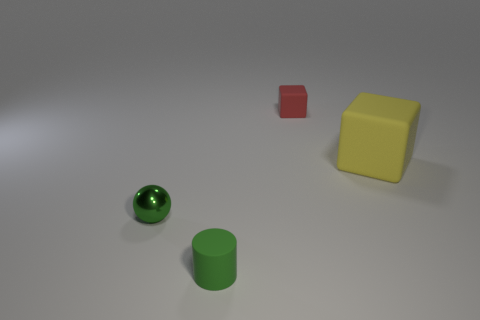What is the size of the object that is the same color as the sphere?
Give a very brief answer. Small. What number of small things are blue cubes or metal balls?
Your answer should be very brief. 1. What number of objects are in front of the small rubber cube and to the right of the green matte object?
Give a very brief answer. 1. Do the large cube and the green object behind the green matte thing have the same material?
Keep it short and to the point. No. What number of cyan things are either big matte objects or metallic objects?
Your answer should be compact. 0. Are there any green things that have the same size as the ball?
Your answer should be compact. Yes. There is a green object in front of the small thing to the left of the green object in front of the green shiny ball; what is it made of?
Ensure brevity in your answer.  Rubber. Are there an equal number of green things right of the green matte thing and yellow matte things?
Provide a succinct answer. No. Is the material of the green object left of the green matte cylinder the same as the small green cylinder that is left of the large yellow matte thing?
Offer a terse response. No. How many objects are big cyan matte cubes or small green objects that are on the right side of the small ball?
Offer a very short reply. 1. 